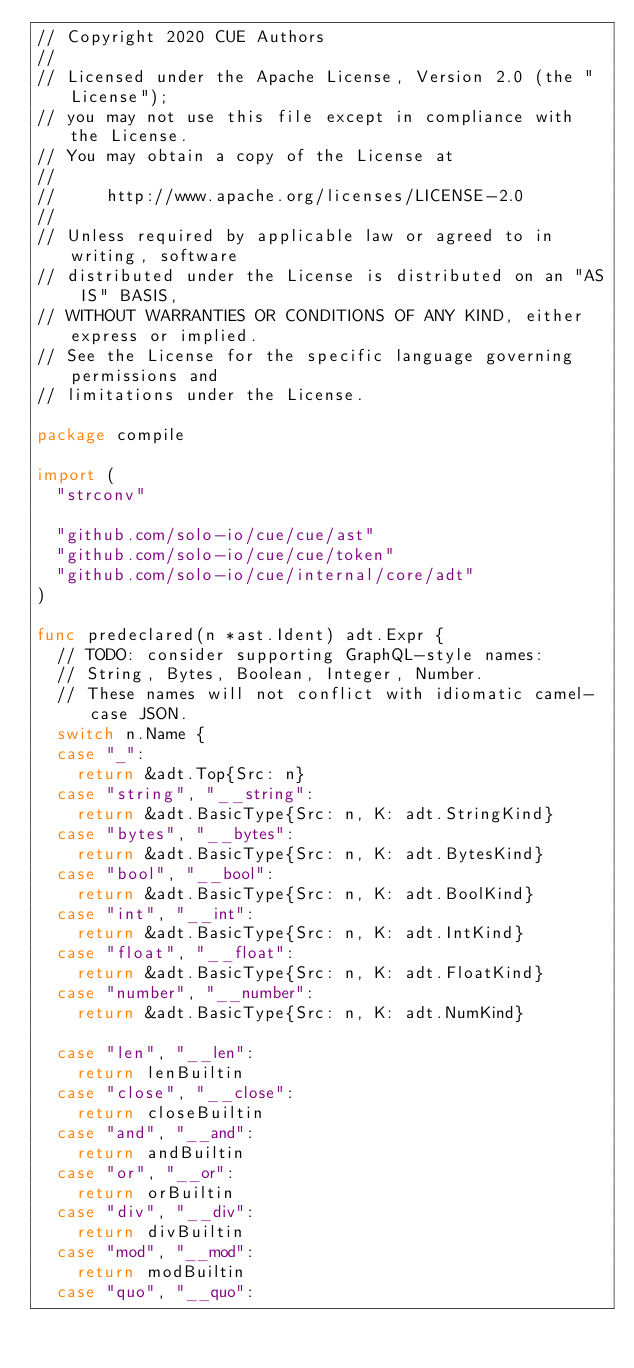<code> <loc_0><loc_0><loc_500><loc_500><_Go_>// Copyright 2020 CUE Authors
//
// Licensed under the Apache License, Version 2.0 (the "License");
// you may not use this file except in compliance with the License.
// You may obtain a copy of the License at
//
//     http://www.apache.org/licenses/LICENSE-2.0
//
// Unless required by applicable law or agreed to in writing, software
// distributed under the License is distributed on an "AS IS" BASIS,
// WITHOUT WARRANTIES OR CONDITIONS OF ANY KIND, either express or implied.
// See the License for the specific language governing permissions and
// limitations under the License.

package compile

import (
	"strconv"

	"github.com/solo-io/cue/cue/ast"
	"github.com/solo-io/cue/cue/token"
	"github.com/solo-io/cue/internal/core/adt"
)

func predeclared(n *ast.Ident) adt.Expr {
	// TODO: consider supporting GraphQL-style names:
	// String, Bytes, Boolean, Integer, Number.
	// These names will not conflict with idiomatic camel-case JSON.
	switch n.Name {
	case "_":
		return &adt.Top{Src: n}
	case "string", "__string":
		return &adt.BasicType{Src: n, K: adt.StringKind}
	case "bytes", "__bytes":
		return &adt.BasicType{Src: n, K: adt.BytesKind}
	case "bool", "__bool":
		return &adt.BasicType{Src: n, K: adt.BoolKind}
	case "int", "__int":
		return &adt.BasicType{Src: n, K: adt.IntKind}
	case "float", "__float":
		return &adt.BasicType{Src: n, K: adt.FloatKind}
	case "number", "__number":
		return &adt.BasicType{Src: n, K: adt.NumKind}

	case "len", "__len":
		return lenBuiltin
	case "close", "__close":
		return closeBuiltin
	case "and", "__and":
		return andBuiltin
	case "or", "__or":
		return orBuiltin
	case "div", "__div":
		return divBuiltin
	case "mod", "__mod":
		return modBuiltin
	case "quo", "__quo":</code> 